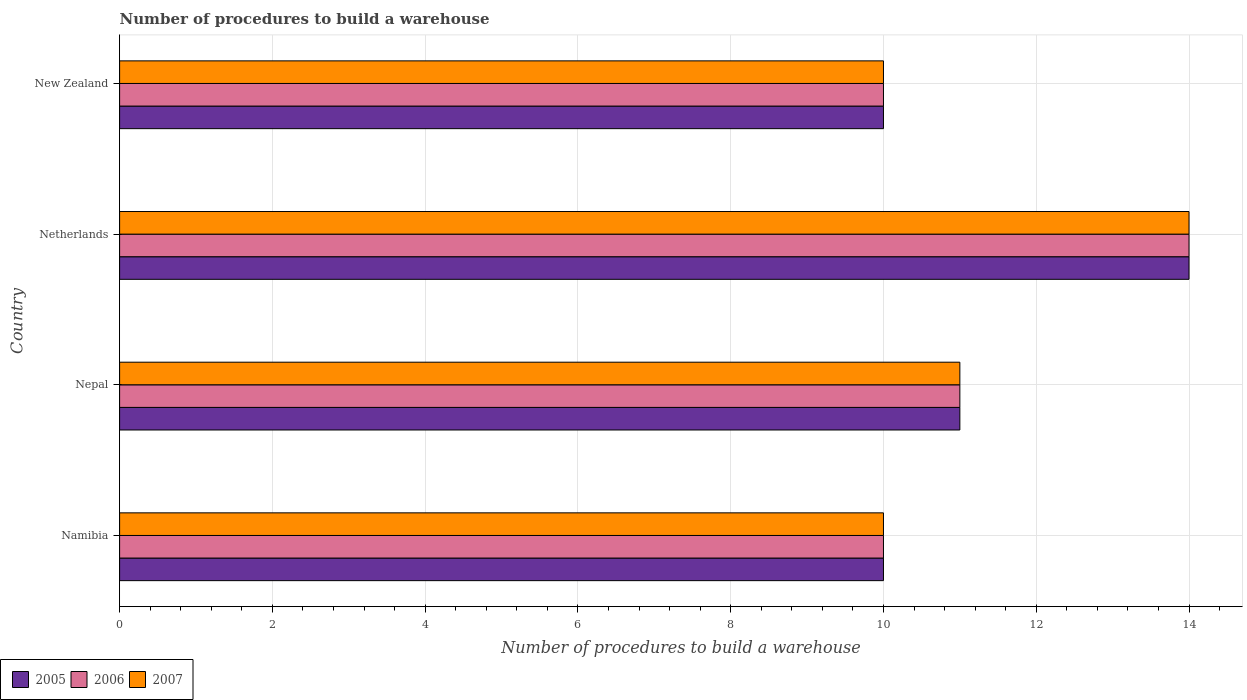Are the number of bars on each tick of the Y-axis equal?
Ensure brevity in your answer.  Yes. How many bars are there on the 1st tick from the top?
Offer a very short reply. 3. What is the label of the 4th group of bars from the top?
Your answer should be very brief. Namibia. In how many cases, is the number of bars for a given country not equal to the number of legend labels?
Offer a very short reply. 0. What is the number of procedures to build a warehouse in in 2007 in Nepal?
Your answer should be very brief. 11. Across all countries, what is the minimum number of procedures to build a warehouse in in 2005?
Keep it short and to the point. 10. In which country was the number of procedures to build a warehouse in in 2007 maximum?
Provide a succinct answer. Netherlands. In which country was the number of procedures to build a warehouse in in 2005 minimum?
Make the answer very short. Namibia. What is the difference between the number of procedures to build a warehouse in in 2005 in New Zealand and the number of procedures to build a warehouse in in 2006 in Netherlands?
Ensure brevity in your answer.  -4. What is the average number of procedures to build a warehouse in in 2005 per country?
Give a very brief answer. 11.25. What is the ratio of the number of procedures to build a warehouse in in 2005 in Nepal to that in New Zealand?
Keep it short and to the point. 1.1. In how many countries, is the number of procedures to build a warehouse in in 2007 greater than the average number of procedures to build a warehouse in in 2007 taken over all countries?
Your answer should be very brief. 1. Are the values on the major ticks of X-axis written in scientific E-notation?
Your answer should be very brief. No. Does the graph contain grids?
Your response must be concise. Yes. Where does the legend appear in the graph?
Provide a succinct answer. Bottom left. What is the title of the graph?
Your response must be concise. Number of procedures to build a warehouse. Does "2006" appear as one of the legend labels in the graph?
Keep it short and to the point. Yes. What is the label or title of the X-axis?
Your answer should be compact. Number of procedures to build a warehouse. What is the label or title of the Y-axis?
Offer a very short reply. Country. What is the Number of procedures to build a warehouse of 2005 in Nepal?
Provide a succinct answer. 11. What is the Number of procedures to build a warehouse of 2006 in Nepal?
Make the answer very short. 11. What is the Number of procedures to build a warehouse of 2005 in Netherlands?
Provide a short and direct response. 14. What is the Number of procedures to build a warehouse in 2005 in New Zealand?
Your response must be concise. 10. What is the Number of procedures to build a warehouse in 2006 in New Zealand?
Your answer should be very brief. 10. Across all countries, what is the maximum Number of procedures to build a warehouse of 2005?
Give a very brief answer. 14. Across all countries, what is the maximum Number of procedures to build a warehouse in 2007?
Your response must be concise. 14. Across all countries, what is the minimum Number of procedures to build a warehouse of 2005?
Your answer should be compact. 10. Across all countries, what is the minimum Number of procedures to build a warehouse in 2006?
Your answer should be compact. 10. What is the difference between the Number of procedures to build a warehouse in 2005 in Namibia and that in Nepal?
Your response must be concise. -1. What is the difference between the Number of procedures to build a warehouse of 2006 in Namibia and that in Nepal?
Offer a terse response. -1. What is the difference between the Number of procedures to build a warehouse of 2007 in Namibia and that in Nepal?
Your answer should be very brief. -1. What is the difference between the Number of procedures to build a warehouse in 2006 in Namibia and that in Netherlands?
Offer a very short reply. -4. What is the difference between the Number of procedures to build a warehouse of 2007 in Namibia and that in New Zealand?
Make the answer very short. 0. What is the difference between the Number of procedures to build a warehouse in 2007 in Nepal and that in Netherlands?
Provide a succinct answer. -3. What is the difference between the Number of procedures to build a warehouse in 2006 in Nepal and that in New Zealand?
Ensure brevity in your answer.  1. What is the difference between the Number of procedures to build a warehouse of 2005 in Netherlands and that in New Zealand?
Provide a succinct answer. 4. What is the difference between the Number of procedures to build a warehouse in 2005 in Namibia and the Number of procedures to build a warehouse in 2007 in New Zealand?
Your answer should be compact. 0. What is the difference between the Number of procedures to build a warehouse of 2006 in Namibia and the Number of procedures to build a warehouse of 2007 in New Zealand?
Your answer should be very brief. 0. What is the difference between the Number of procedures to build a warehouse in 2006 in Nepal and the Number of procedures to build a warehouse in 2007 in Netherlands?
Your response must be concise. -3. What is the difference between the Number of procedures to build a warehouse in 2005 in Nepal and the Number of procedures to build a warehouse in 2007 in New Zealand?
Your response must be concise. 1. What is the difference between the Number of procedures to build a warehouse in 2006 in Nepal and the Number of procedures to build a warehouse in 2007 in New Zealand?
Your answer should be compact. 1. What is the difference between the Number of procedures to build a warehouse in 2005 in Netherlands and the Number of procedures to build a warehouse in 2006 in New Zealand?
Offer a terse response. 4. What is the difference between the Number of procedures to build a warehouse in 2005 in Netherlands and the Number of procedures to build a warehouse in 2007 in New Zealand?
Offer a terse response. 4. What is the difference between the Number of procedures to build a warehouse of 2006 in Netherlands and the Number of procedures to build a warehouse of 2007 in New Zealand?
Ensure brevity in your answer.  4. What is the average Number of procedures to build a warehouse in 2005 per country?
Offer a very short reply. 11.25. What is the average Number of procedures to build a warehouse of 2006 per country?
Offer a very short reply. 11.25. What is the average Number of procedures to build a warehouse in 2007 per country?
Your answer should be compact. 11.25. What is the difference between the Number of procedures to build a warehouse of 2005 and Number of procedures to build a warehouse of 2007 in Namibia?
Provide a short and direct response. 0. What is the difference between the Number of procedures to build a warehouse of 2005 and Number of procedures to build a warehouse of 2006 in Nepal?
Ensure brevity in your answer.  0. What is the difference between the Number of procedures to build a warehouse of 2006 and Number of procedures to build a warehouse of 2007 in Nepal?
Give a very brief answer. 0. What is the difference between the Number of procedures to build a warehouse in 2005 and Number of procedures to build a warehouse in 2007 in Netherlands?
Provide a succinct answer. 0. What is the difference between the Number of procedures to build a warehouse of 2005 and Number of procedures to build a warehouse of 2007 in New Zealand?
Give a very brief answer. 0. What is the difference between the Number of procedures to build a warehouse of 2006 and Number of procedures to build a warehouse of 2007 in New Zealand?
Ensure brevity in your answer.  0. What is the ratio of the Number of procedures to build a warehouse of 2006 in Namibia to that in Nepal?
Keep it short and to the point. 0.91. What is the ratio of the Number of procedures to build a warehouse in 2007 in Namibia to that in Nepal?
Keep it short and to the point. 0.91. What is the ratio of the Number of procedures to build a warehouse in 2005 in Nepal to that in Netherlands?
Make the answer very short. 0.79. What is the ratio of the Number of procedures to build a warehouse in 2006 in Nepal to that in Netherlands?
Your answer should be compact. 0.79. What is the ratio of the Number of procedures to build a warehouse of 2007 in Nepal to that in Netherlands?
Provide a short and direct response. 0.79. What is the ratio of the Number of procedures to build a warehouse in 2007 in Nepal to that in New Zealand?
Offer a terse response. 1.1. What is the ratio of the Number of procedures to build a warehouse in 2006 in Netherlands to that in New Zealand?
Your response must be concise. 1.4. What is the difference between the highest and the second highest Number of procedures to build a warehouse in 2005?
Keep it short and to the point. 3. What is the difference between the highest and the second highest Number of procedures to build a warehouse of 2007?
Provide a succinct answer. 3. What is the difference between the highest and the lowest Number of procedures to build a warehouse in 2005?
Give a very brief answer. 4. 